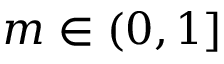<formula> <loc_0><loc_0><loc_500><loc_500>m \in ( 0 , 1 ]</formula> 